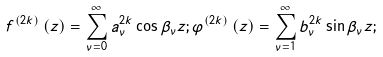Convert formula to latex. <formula><loc_0><loc_0><loc_500><loc_500>f ^ { \left ( 2 k \right ) } \left ( z \right ) = \sum _ { \nu = 0 } ^ { \infty } a _ { \nu } ^ { 2 k } \cos \beta _ { \nu } z ; \varphi ^ { \left ( 2 k \right ) } \left ( z \right ) = \sum _ { \nu = 1 } ^ { \infty } b _ { \nu } ^ { 2 k } \sin \beta _ { \nu } z ;</formula> 